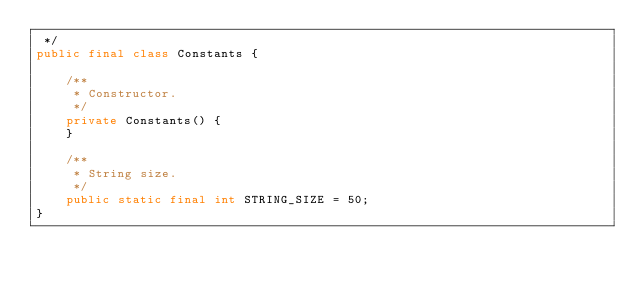Convert code to text. <code><loc_0><loc_0><loc_500><loc_500><_Java_> */
public final class Constants {

    /**
     * Constructor.
     */
    private Constants() {
    }

    /**
     * String size.
     */
    public static final int STRING_SIZE = 50;
}
</code> 